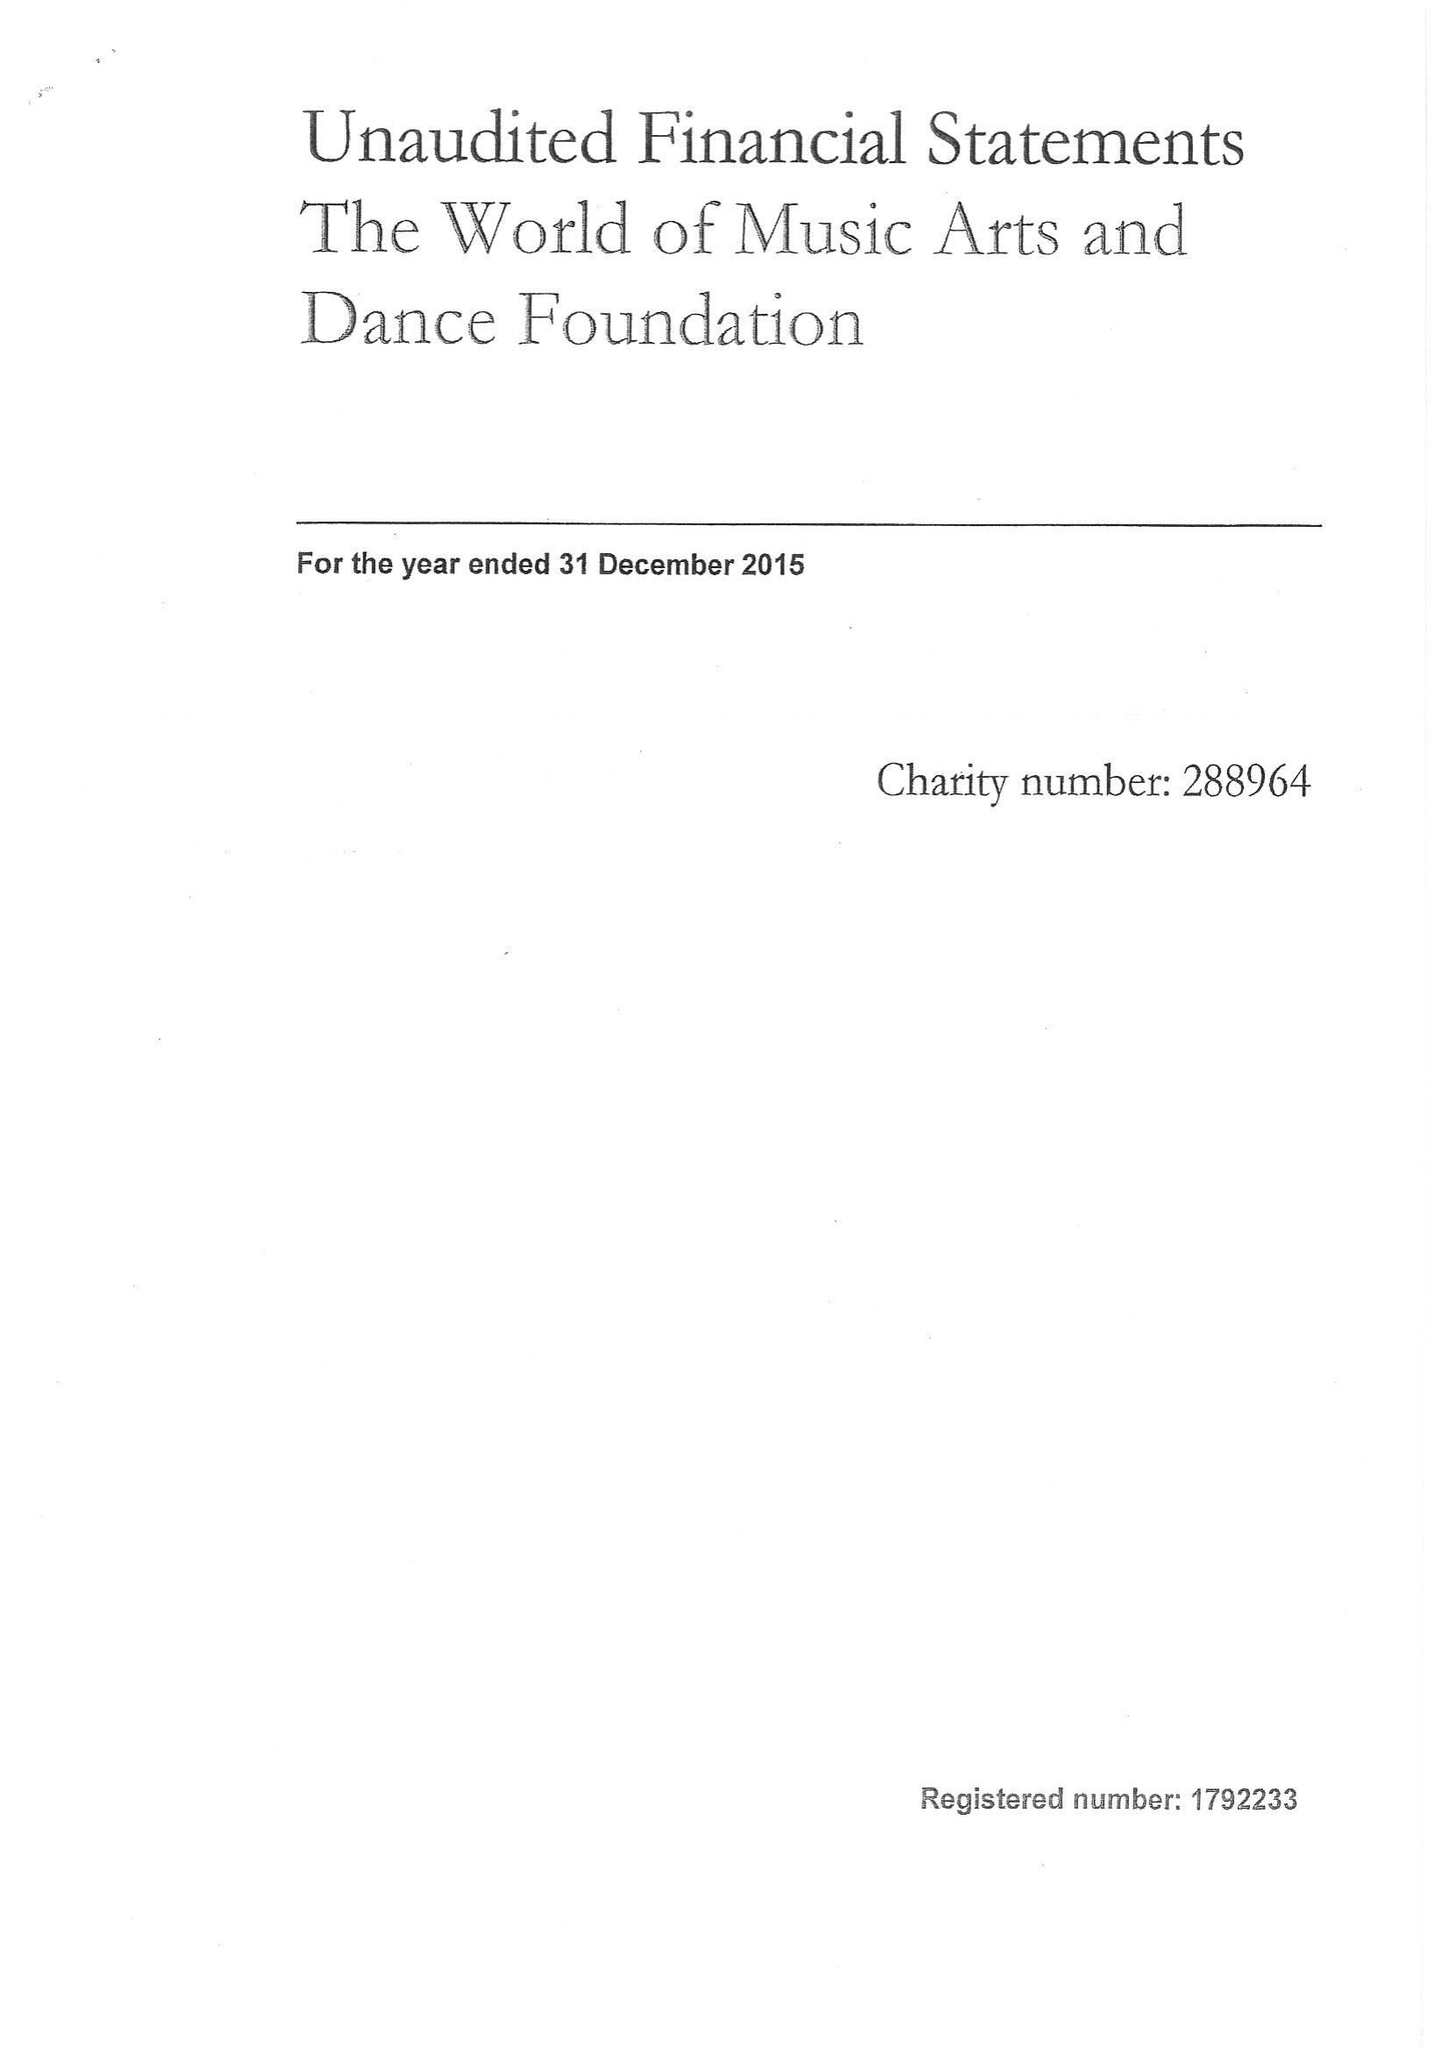What is the value for the address__post_town?
Answer the question using a single word or phrase. CORSHAM 